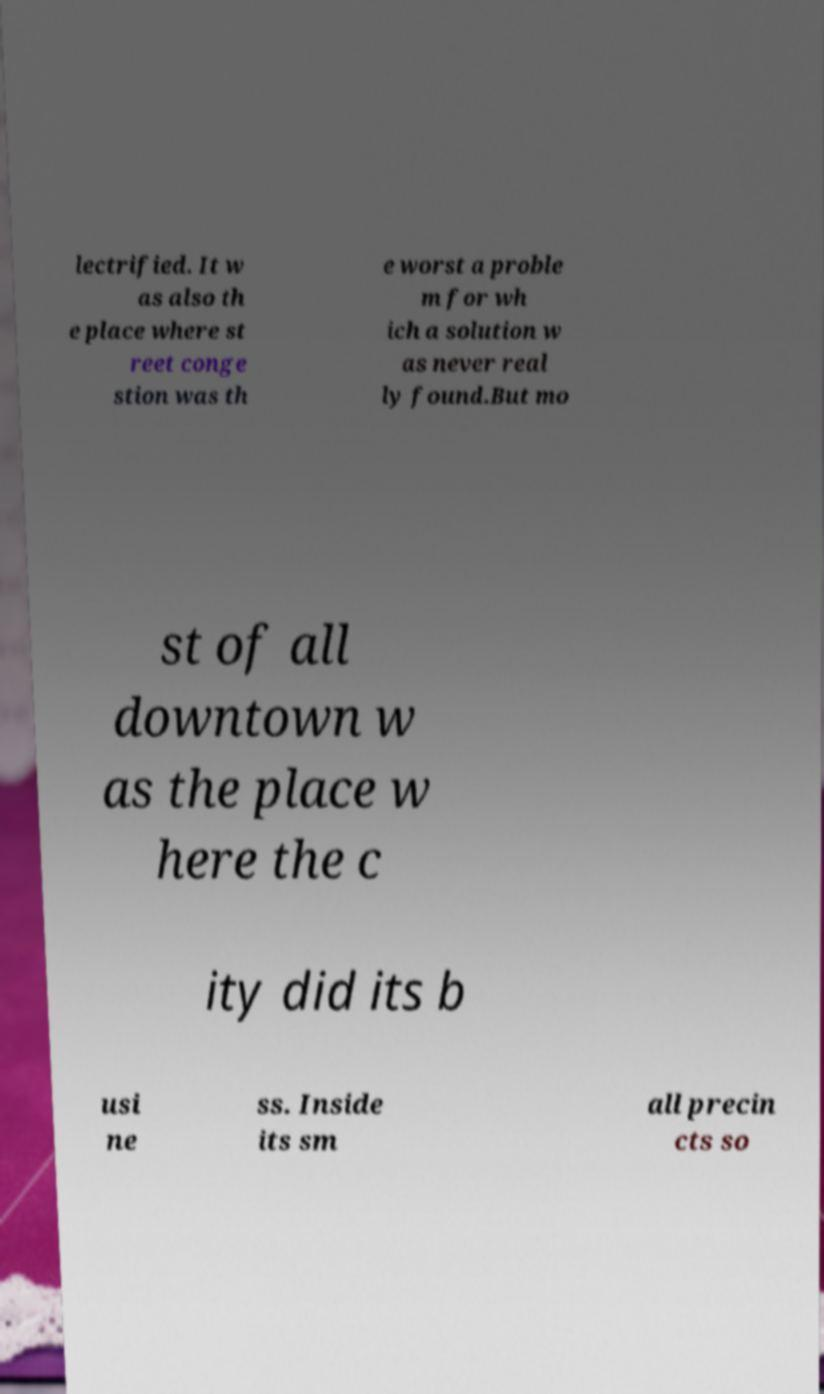Could you assist in decoding the text presented in this image and type it out clearly? lectrified. It w as also th e place where st reet conge stion was th e worst a proble m for wh ich a solution w as never real ly found.But mo st of all downtown w as the place w here the c ity did its b usi ne ss. Inside its sm all precin cts so 